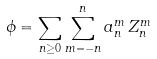Convert formula to latex. <formula><loc_0><loc_0><loc_500><loc_500>\phi = \sum _ { n \geq 0 } \sum _ { m = - n } ^ { n } a _ { n } ^ { m } \, Z _ { n } ^ { m }</formula> 